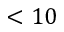<formula> <loc_0><loc_0><loc_500><loc_500>< 1 0</formula> 